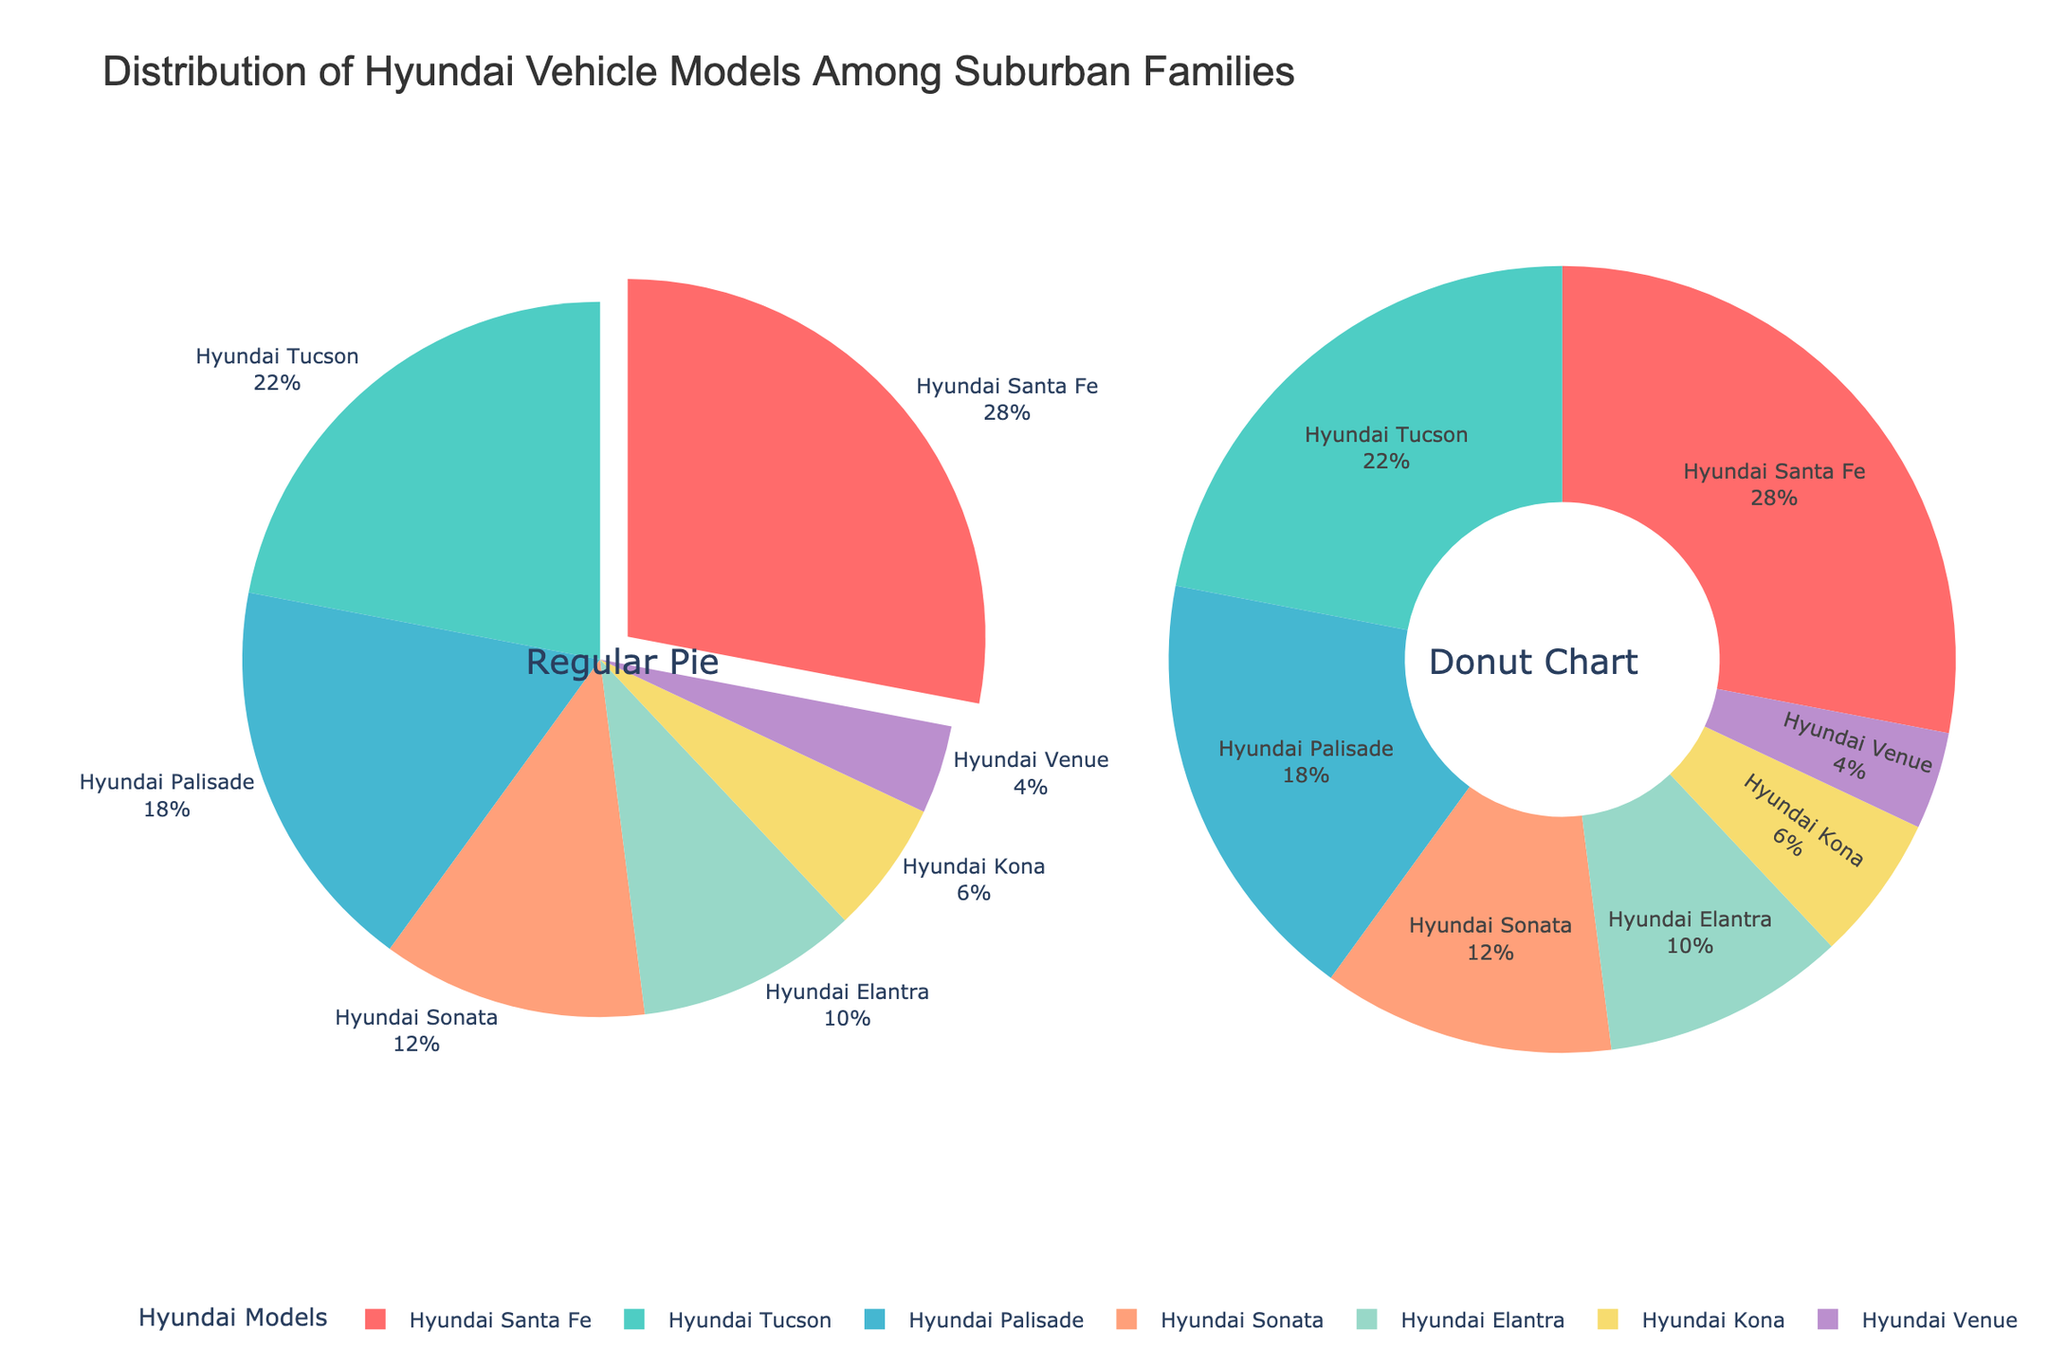what is the title of the figure? The title of the figure is displayed prominently at the top. It reads "Distribution of Hyundai Vehicle Models Among Suburban Families".
Answer: Distribution of Hyundai Vehicle Models Among Suburban Families Which Hyundai model has the largest percentage? To find the Hyundai model with the largest percentage, look at the slices of the pie charts or the labels with percentages. The Hyundai Santa Fe has the largest slice.
Answer: Hyundai Santa Fe What is the combined percentage of Hyundai Tucson and Hyundai Palisade? To calculate the combined percentage, add the percentage values of Hyundai Tucson (22%) and Hyundai Palisade (18%). So, 22% + 18% = 40%.
Answer: 40% Which model has the smallest share among suburban families? The smallest share can be identified by the smallest slice in the pie charts or the label with the smallest percentage. The Hyundai Venue has the smallest share with 4%.
Answer: Hyundai Venue How do the visual styles differ between the two subplots? The left pie chart is a regular pie chart with labels and percentages outside, while the right pie chart is a donut chart with a hole in the middle and labels inside.
Answer: Regular pie chart vs Donut chart If you combine the shares of Hyundai Sonata and Hyundai Elantra, will they surpass the Hyundai Santa Fe's percentage? First, sum the percentages of Hyundai Sonata (12%) and Hyundai Elantra (10%), which equals 22%. The Hyundai Santa Fe's share is 28%, so 22% does not surpass 28%.
Answer: No What percentage of the distribution does the Hyundai Kona have? From the pie charts, the label for Hyundai Kona shows that it has a percentage of 6%.
Answer: 6% How much more popular is the Hyundai Santa Fe compared to the Hyundai Venue? Subtract the percentage of Hyundai Venue (4%) from Hyundai Santa Fe (28%) to determine the difference. So, 28% - 4% = 24% more popular.
Answer: 24% more popular Which models together make up over half of the distribution? Adding up percentages from largest to smallest: Hyundai Santa Fe (28%) + Hyundai Tucson (22%) = 50%, which is exactly half, so these two models together make up half of the distribution.
Answer: Hyundai Santa Fe and Hyundai Tucson 